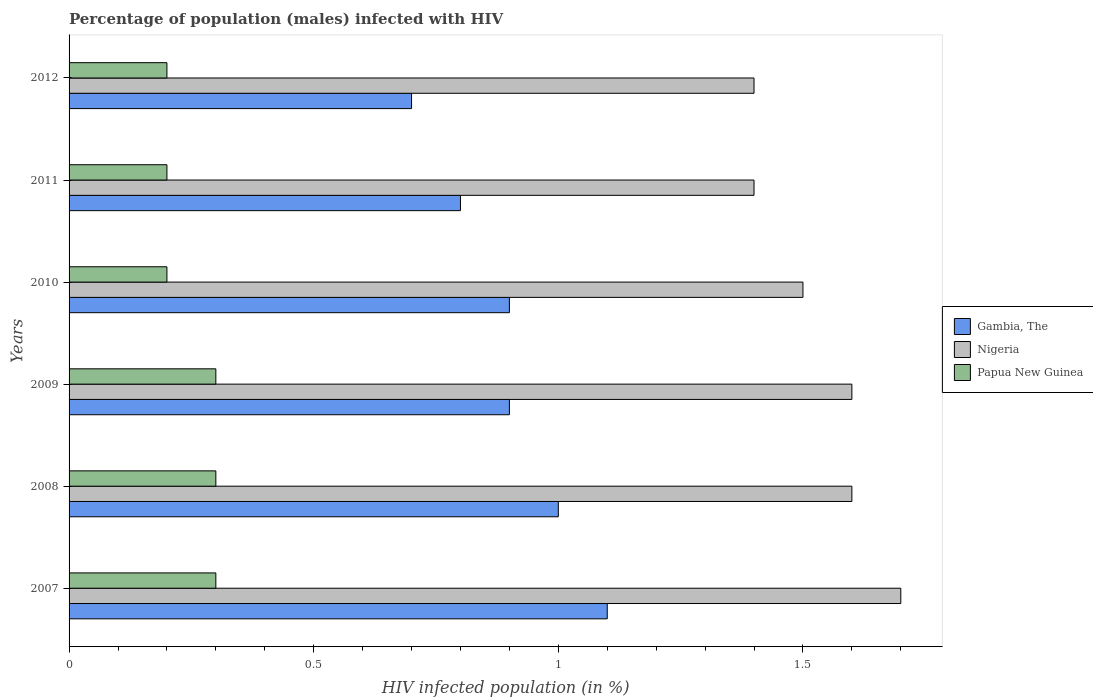Are the number of bars on each tick of the Y-axis equal?
Ensure brevity in your answer.  Yes. Across all years, what is the maximum percentage of HIV infected male population in Gambia, The?
Your answer should be compact. 1.1. In which year was the percentage of HIV infected male population in Gambia, The maximum?
Your answer should be compact. 2007. In which year was the percentage of HIV infected male population in Papua New Guinea minimum?
Your answer should be very brief. 2010. What is the total percentage of HIV infected male population in Papua New Guinea in the graph?
Your answer should be compact. 1.5. What is the difference between the percentage of HIV infected male population in Nigeria in 2008 and that in 2010?
Make the answer very short. 0.1. What is the difference between the percentage of HIV infected male population in Papua New Guinea in 2011 and the percentage of HIV infected male population in Gambia, The in 2012?
Give a very brief answer. -0.5. What is the average percentage of HIV infected male population in Papua New Guinea per year?
Offer a terse response. 0.25. In the year 2008, what is the difference between the percentage of HIV infected male population in Gambia, The and percentage of HIV infected male population in Papua New Guinea?
Ensure brevity in your answer.  0.7. Is the percentage of HIV infected male population in Nigeria in 2007 less than that in 2009?
Provide a succinct answer. No. What is the difference between the highest and the lowest percentage of HIV infected male population in Papua New Guinea?
Your response must be concise. 0.1. In how many years, is the percentage of HIV infected male population in Papua New Guinea greater than the average percentage of HIV infected male population in Papua New Guinea taken over all years?
Give a very brief answer. 3. Is the sum of the percentage of HIV infected male population in Papua New Guinea in 2010 and 2011 greater than the maximum percentage of HIV infected male population in Nigeria across all years?
Offer a very short reply. No. What does the 3rd bar from the top in 2010 represents?
Your answer should be compact. Gambia, The. What does the 3rd bar from the bottom in 2007 represents?
Your answer should be very brief. Papua New Guinea. Is it the case that in every year, the sum of the percentage of HIV infected male population in Gambia, The and percentage of HIV infected male population in Papua New Guinea is greater than the percentage of HIV infected male population in Nigeria?
Your answer should be very brief. No. Are all the bars in the graph horizontal?
Your answer should be very brief. Yes. Does the graph contain any zero values?
Offer a terse response. No. Where does the legend appear in the graph?
Keep it short and to the point. Center right. How many legend labels are there?
Your answer should be very brief. 3. What is the title of the graph?
Ensure brevity in your answer.  Percentage of population (males) infected with HIV. Does "Bolivia" appear as one of the legend labels in the graph?
Offer a terse response. No. What is the label or title of the X-axis?
Make the answer very short. HIV infected population (in %). What is the label or title of the Y-axis?
Your answer should be compact. Years. What is the HIV infected population (in %) in Nigeria in 2008?
Your answer should be compact. 1.6. What is the HIV infected population (in %) in Gambia, The in 2009?
Your answer should be very brief. 0.9. What is the HIV infected population (in %) of Nigeria in 2011?
Offer a very short reply. 1.4. What is the HIV infected population (in %) of Nigeria in 2012?
Provide a short and direct response. 1.4. Across all years, what is the maximum HIV infected population (in %) in Papua New Guinea?
Your response must be concise. 0.3. Across all years, what is the minimum HIV infected population (in %) in Gambia, The?
Make the answer very short. 0.7. Across all years, what is the minimum HIV infected population (in %) in Nigeria?
Keep it short and to the point. 1.4. Across all years, what is the minimum HIV infected population (in %) of Papua New Guinea?
Keep it short and to the point. 0.2. What is the total HIV infected population (in %) of Gambia, The in the graph?
Make the answer very short. 5.4. What is the total HIV infected population (in %) in Nigeria in the graph?
Give a very brief answer. 9.2. What is the difference between the HIV infected population (in %) in Gambia, The in 2007 and that in 2008?
Your answer should be very brief. 0.1. What is the difference between the HIV infected population (in %) of Papua New Guinea in 2007 and that in 2008?
Your answer should be very brief. 0. What is the difference between the HIV infected population (in %) of Papua New Guinea in 2007 and that in 2010?
Ensure brevity in your answer.  0.1. What is the difference between the HIV infected population (in %) of Gambia, The in 2007 and that in 2011?
Give a very brief answer. 0.3. What is the difference between the HIV infected population (in %) in Papua New Guinea in 2007 and that in 2011?
Provide a short and direct response. 0.1. What is the difference between the HIV infected population (in %) of Gambia, The in 2007 and that in 2012?
Provide a succinct answer. 0.4. What is the difference between the HIV infected population (in %) in Papua New Guinea in 2007 and that in 2012?
Your answer should be compact. 0.1. What is the difference between the HIV infected population (in %) in Papua New Guinea in 2008 and that in 2009?
Keep it short and to the point. 0. What is the difference between the HIV infected population (in %) of Papua New Guinea in 2008 and that in 2010?
Your answer should be very brief. 0.1. What is the difference between the HIV infected population (in %) in Nigeria in 2008 and that in 2011?
Provide a succinct answer. 0.2. What is the difference between the HIV infected population (in %) of Gambia, The in 2008 and that in 2012?
Keep it short and to the point. 0.3. What is the difference between the HIV infected population (in %) in Papua New Guinea in 2008 and that in 2012?
Ensure brevity in your answer.  0.1. What is the difference between the HIV infected population (in %) in Papua New Guinea in 2009 and that in 2010?
Offer a terse response. 0.1. What is the difference between the HIV infected population (in %) of Nigeria in 2009 and that in 2011?
Provide a succinct answer. 0.2. What is the difference between the HIV infected population (in %) in Nigeria in 2009 and that in 2012?
Make the answer very short. 0.2. What is the difference between the HIV infected population (in %) of Papua New Guinea in 2009 and that in 2012?
Offer a terse response. 0.1. What is the difference between the HIV infected population (in %) of Gambia, The in 2010 and that in 2012?
Keep it short and to the point. 0.2. What is the difference between the HIV infected population (in %) of Nigeria in 2010 and that in 2012?
Ensure brevity in your answer.  0.1. What is the difference between the HIV infected population (in %) in Papua New Guinea in 2010 and that in 2012?
Your answer should be very brief. 0. What is the difference between the HIV infected population (in %) of Gambia, The in 2011 and that in 2012?
Keep it short and to the point. 0.1. What is the difference between the HIV infected population (in %) of Gambia, The in 2007 and the HIV infected population (in %) of Nigeria in 2008?
Offer a very short reply. -0.5. What is the difference between the HIV infected population (in %) in Gambia, The in 2007 and the HIV infected population (in %) in Nigeria in 2009?
Your response must be concise. -0.5. What is the difference between the HIV infected population (in %) of Gambia, The in 2007 and the HIV infected population (in %) of Papua New Guinea in 2009?
Your response must be concise. 0.8. What is the difference between the HIV infected population (in %) of Nigeria in 2007 and the HIV infected population (in %) of Papua New Guinea in 2009?
Your answer should be very brief. 1.4. What is the difference between the HIV infected population (in %) in Gambia, The in 2007 and the HIV infected population (in %) in Nigeria in 2010?
Keep it short and to the point. -0.4. What is the difference between the HIV infected population (in %) of Gambia, The in 2007 and the HIV infected population (in %) of Papua New Guinea in 2010?
Give a very brief answer. 0.9. What is the difference between the HIV infected population (in %) of Nigeria in 2007 and the HIV infected population (in %) of Papua New Guinea in 2010?
Give a very brief answer. 1.5. What is the difference between the HIV infected population (in %) in Gambia, The in 2007 and the HIV infected population (in %) in Nigeria in 2011?
Your answer should be compact. -0.3. What is the difference between the HIV infected population (in %) in Gambia, The in 2007 and the HIV infected population (in %) in Papua New Guinea in 2011?
Your answer should be compact. 0.9. What is the difference between the HIV infected population (in %) in Nigeria in 2007 and the HIV infected population (in %) in Papua New Guinea in 2011?
Offer a very short reply. 1.5. What is the difference between the HIV infected population (in %) of Gambia, The in 2007 and the HIV infected population (in %) of Nigeria in 2012?
Your response must be concise. -0.3. What is the difference between the HIV infected population (in %) in Gambia, The in 2007 and the HIV infected population (in %) in Papua New Guinea in 2012?
Offer a terse response. 0.9. What is the difference between the HIV infected population (in %) in Gambia, The in 2008 and the HIV infected population (in %) in Nigeria in 2010?
Offer a very short reply. -0.5. What is the difference between the HIV infected population (in %) of Nigeria in 2008 and the HIV infected population (in %) of Papua New Guinea in 2010?
Your answer should be compact. 1.4. What is the difference between the HIV infected population (in %) in Nigeria in 2008 and the HIV infected population (in %) in Papua New Guinea in 2011?
Offer a very short reply. 1.4. What is the difference between the HIV infected population (in %) in Gambia, The in 2008 and the HIV infected population (in %) in Nigeria in 2012?
Provide a short and direct response. -0.4. What is the difference between the HIV infected population (in %) of Nigeria in 2008 and the HIV infected population (in %) of Papua New Guinea in 2012?
Provide a short and direct response. 1.4. What is the difference between the HIV infected population (in %) of Gambia, The in 2009 and the HIV infected population (in %) of Nigeria in 2010?
Keep it short and to the point. -0.6. What is the difference between the HIV infected population (in %) in Nigeria in 2009 and the HIV infected population (in %) in Papua New Guinea in 2010?
Make the answer very short. 1.4. What is the difference between the HIV infected population (in %) of Gambia, The in 2009 and the HIV infected population (in %) of Nigeria in 2011?
Ensure brevity in your answer.  -0.5. What is the difference between the HIV infected population (in %) in Nigeria in 2009 and the HIV infected population (in %) in Papua New Guinea in 2011?
Your answer should be very brief. 1.4. What is the difference between the HIV infected population (in %) of Gambia, The in 2009 and the HIV infected population (in %) of Nigeria in 2012?
Give a very brief answer. -0.5. What is the difference between the HIV infected population (in %) of Gambia, The in 2009 and the HIV infected population (in %) of Papua New Guinea in 2012?
Make the answer very short. 0.7. What is the difference between the HIV infected population (in %) of Nigeria in 2009 and the HIV infected population (in %) of Papua New Guinea in 2012?
Your response must be concise. 1.4. What is the difference between the HIV infected population (in %) of Gambia, The in 2010 and the HIV infected population (in %) of Nigeria in 2011?
Provide a short and direct response. -0.5. What is the difference between the HIV infected population (in %) in Gambia, The in 2010 and the HIV infected population (in %) in Papua New Guinea in 2011?
Your answer should be compact. 0.7. What is the difference between the HIV infected population (in %) of Nigeria in 2010 and the HIV infected population (in %) of Papua New Guinea in 2011?
Offer a very short reply. 1.3. What is the difference between the HIV infected population (in %) in Gambia, The in 2010 and the HIV infected population (in %) in Papua New Guinea in 2012?
Provide a short and direct response. 0.7. What is the difference between the HIV infected population (in %) in Nigeria in 2010 and the HIV infected population (in %) in Papua New Guinea in 2012?
Your response must be concise. 1.3. What is the difference between the HIV infected population (in %) in Gambia, The in 2011 and the HIV infected population (in %) in Papua New Guinea in 2012?
Provide a short and direct response. 0.6. What is the difference between the HIV infected population (in %) in Nigeria in 2011 and the HIV infected population (in %) in Papua New Guinea in 2012?
Your response must be concise. 1.2. What is the average HIV infected population (in %) in Nigeria per year?
Make the answer very short. 1.53. What is the average HIV infected population (in %) of Papua New Guinea per year?
Your response must be concise. 0.25. In the year 2007, what is the difference between the HIV infected population (in %) of Gambia, The and HIV infected population (in %) of Nigeria?
Make the answer very short. -0.6. In the year 2007, what is the difference between the HIV infected population (in %) in Gambia, The and HIV infected population (in %) in Papua New Guinea?
Give a very brief answer. 0.8. In the year 2008, what is the difference between the HIV infected population (in %) in Gambia, The and HIV infected population (in %) in Papua New Guinea?
Your response must be concise. 0.7. In the year 2008, what is the difference between the HIV infected population (in %) in Nigeria and HIV infected population (in %) in Papua New Guinea?
Provide a short and direct response. 1.3. In the year 2009, what is the difference between the HIV infected population (in %) of Gambia, The and HIV infected population (in %) of Nigeria?
Offer a very short reply. -0.7. In the year 2010, what is the difference between the HIV infected population (in %) in Gambia, The and HIV infected population (in %) in Nigeria?
Give a very brief answer. -0.6. In the year 2010, what is the difference between the HIV infected population (in %) of Gambia, The and HIV infected population (in %) of Papua New Guinea?
Your response must be concise. 0.7. In the year 2011, what is the difference between the HIV infected population (in %) in Gambia, The and HIV infected population (in %) in Nigeria?
Provide a succinct answer. -0.6. In the year 2012, what is the difference between the HIV infected population (in %) in Gambia, The and HIV infected population (in %) in Nigeria?
Your answer should be compact. -0.7. In the year 2012, what is the difference between the HIV infected population (in %) in Gambia, The and HIV infected population (in %) in Papua New Guinea?
Your answer should be very brief. 0.5. In the year 2012, what is the difference between the HIV infected population (in %) in Nigeria and HIV infected population (in %) in Papua New Guinea?
Provide a short and direct response. 1.2. What is the ratio of the HIV infected population (in %) in Gambia, The in 2007 to that in 2008?
Give a very brief answer. 1.1. What is the ratio of the HIV infected population (in %) in Nigeria in 2007 to that in 2008?
Offer a terse response. 1.06. What is the ratio of the HIV infected population (in %) in Gambia, The in 2007 to that in 2009?
Provide a succinct answer. 1.22. What is the ratio of the HIV infected population (in %) in Gambia, The in 2007 to that in 2010?
Your answer should be compact. 1.22. What is the ratio of the HIV infected population (in %) in Nigeria in 2007 to that in 2010?
Offer a very short reply. 1.13. What is the ratio of the HIV infected population (in %) in Papua New Guinea in 2007 to that in 2010?
Ensure brevity in your answer.  1.5. What is the ratio of the HIV infected population (in %) in Gambia, The in 2007 to that in 2011?
Your answer should be compact. 1.38. What is the ratio of the HIV infected population (in %) in Nigeria in 2007 to that in 2011?
Provide a short and direct response. 1.21. What is the ratio of the HIV infected population (in %) in Gambia, The in 2007 to that in 2012?
Give a very brief answer. 1.57. What is the ratio of the HIV infected population (in %) in Nigeria in 2007 to that in 2012?
Your response must be concise. 1.21. What is the ratio of the HIV infected population (in %) in Gambia, The in 2008 to that in 2009?
Your answer should be compact. 1.11. What is the ratio of the HIV infected population (in %) in Papua New Guinea in 2008 to that in 2009?
Offer a terse response. 1. What is the ratio of the HIV infected population (in %) in Gambia, The in 2008 to that in 2010?
Your answer should be compact. 1.11. What is the ratio of the HIV infected population (in %) of Nigeria in 2008 to that in 2010?
Your response must be concise. 1.07. What is the ratio of the HIV infected population (in %) of Papua New Guinea in 2008 to that in 2010?
Keep it short and to the point. 1.5. What is the ratio of the HIV infected population (in %) in Nigeria in 2008 to that in 2011?
Your answer should be very brief. 1.14. What is the ratio of the HIV infected population (in %) of Papua New Guinea in 2008 to that in 2011?
Keep it short and to the point. 1.5. What is the ratio of the HIV infected population (in %) of Gambia, The in 2008 to that in 2012?
Provide a short and direct response. 1.43. What is the ratio of the HIV infected population (in %) in Nigeria in 2008 to that in 2012?
Keep it short and to the point. 1.14. What is the ratio of the HIV infected population (in %) of Papua New Guinea in 2008 to that in 2012?
Ensure brevity in your answer.  1.5. What is the ratio of the HIV infected population (in %) in Gambia, The in 2009 to that in 2010?
Your answer should be very brief. 1. What is the ratio of the HIV infected population (in %) of Nigeria in 2009 to that in 2010?
Your answer should be compact. 1.07. What is the ratio of the HIV infected population (in %) in Papua New Guinea in 2009 to that in 2010?
Give a very brief answer. 1.5. What is the ratio of the HIV infected population (in %) in Gambia, The in 2009 to that in 2011?
Keep it short and to the point. 1.12. What is the ratio of the HIV infected population (in %) of Papua New Guinea in 2009 to that in 2011?
Make the answer very short. 1.5. What is the ratio of the HIV infected population (in %) of Gambia, The in 2009 to that in 2012?
Provide a succinct answer. 1.29. What is the ratio of the HIV infected population (in %) of Nigeria in 2010 to that in 2011?
Provide a short and direct response. 1.07. What is the ratio of the HIV infected population (in %) in Nigeria in 2010 to that in 2012?
Your response must be concise. 1.07. What is the ratio of the HIV infected population (in %) in Papua New Guinea in 2010 to that in 2012?
Make the answer very short. 1. What is the difference between the highest and the second highest HIV infected population (in %) in Gambia, The?
Your answer should be compact. 0.1. 